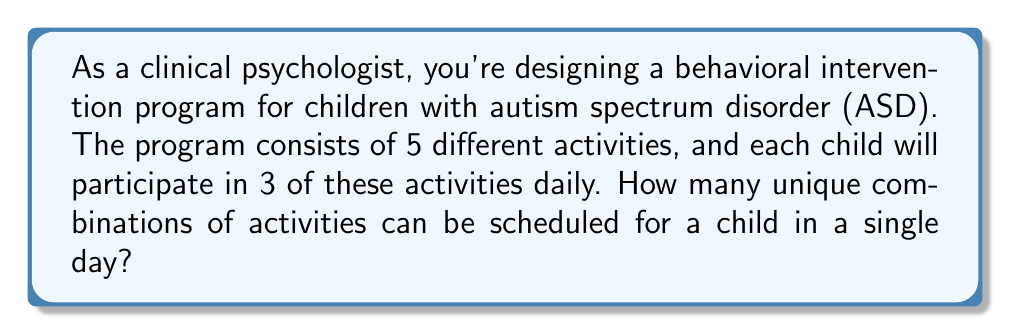What is the answer to this math problem? Let's approach this step-by-step using combinatorics:

1) We have a total of 5 activities to choose from, and we need to select 3 for each day.

2) The order of selection doesn't matter (e.g., doing activity A then B is the same as doing B then A in terms of the overall intervention).

3) This scenario fits the combination formula, which is:

   $$C(n,r) = \frac{n!}{r!(n-r)!}$$

   Where $n$ is the total number of items to choose from, and $r$ is the number of items being chosen.

4) In this case, $n = 5$ (total activities) and $r = 3$ (activities per day).

5) Let's substitute these values into the formula:

   $$C(5,3) = \frac{5!}{3!(5-3)!} = \frac{5!}{3!2!}$$

6) Expand this:
   $$\frac{5 \times 4 \times 3!}{3! \times 2 \times 1}$$

7) The 3! cancels out in the numerator and denominator:
   $$\frac{5 \times 4}{2 \times 1} = \frac{20}{2} = 10$$

Therefore, there are 10 unique combinations of activities that can be scheduled for a child in a single day.
Answer: 10 combinations 